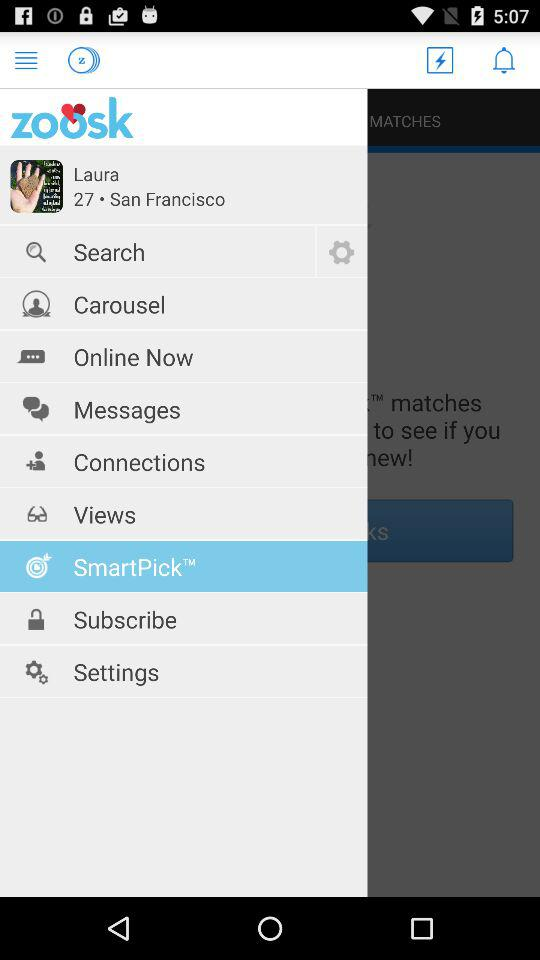What is the user name? The user name is Laura. 